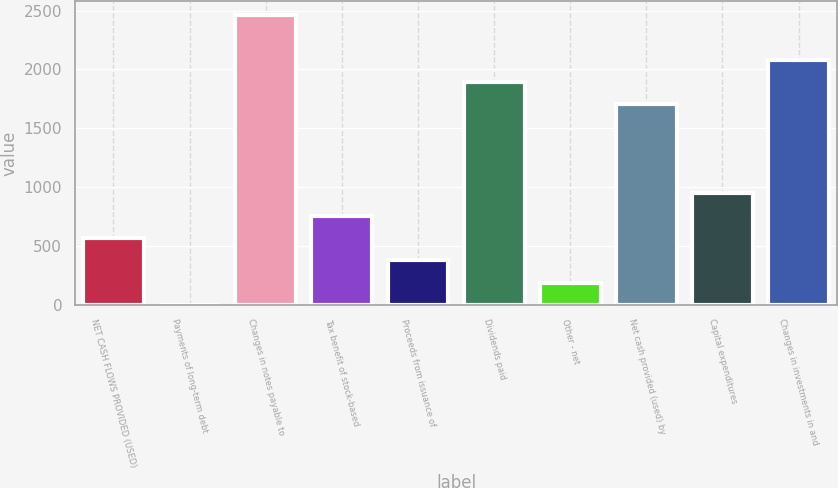Convert chart to OTSL. <chart><loc_0><loc_0><loc_500><loc_500><bar_chart><fcel>NET CASH FLOWS PROVIDED (USED)<fcel>Payments of long-term debt<fcel>Changes in notes payable to<fcel>Tax benefit of stock-based<fcel>Proceeds from issuance of<fcel>Dividends paid<fcel>Other - net<fcel>Net cash provided (used) by<fcel>Capital expenditures<fcel>Changes in investments in and<nl><fcel>568.3<fcel>1<fcel>2459.3<fcel>757.4<fcel>379.2<fcel>1892<fcel>190.1<fcel>1702.9<fcel>946.5<fcel>2081.1<nl></chart> 